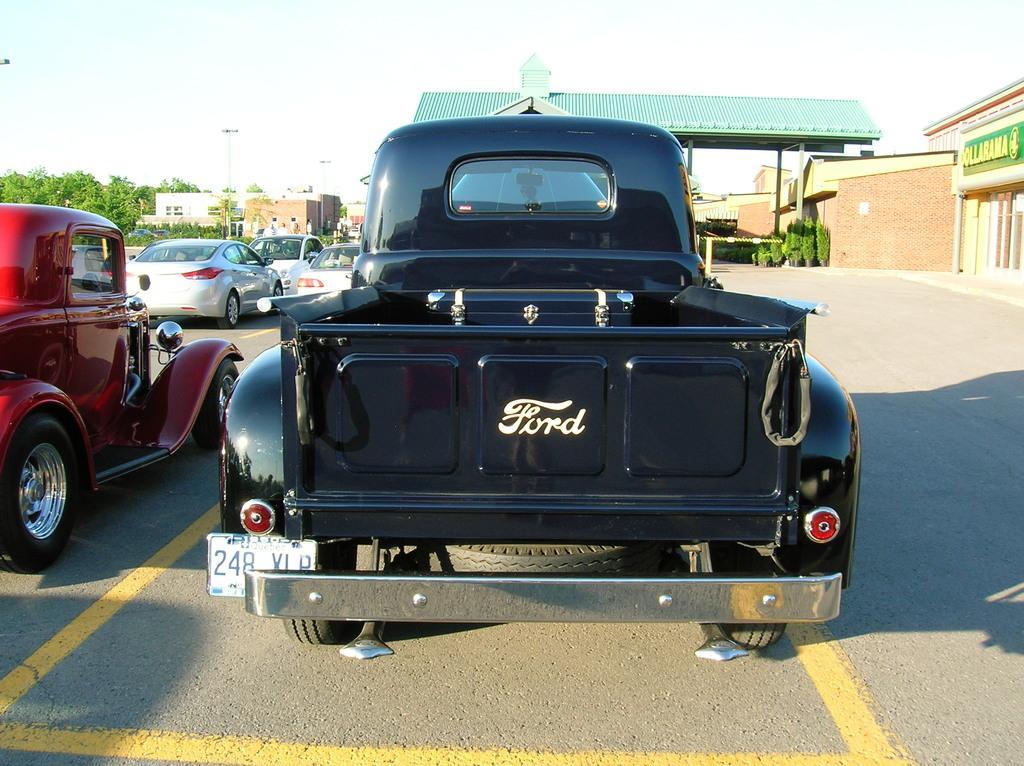How would you summarize this image in a sentence or two? In this image, there are a few vehicles, houses, poles, trees, plants. We can see the ground and the shed. We can see the sky and some text on the right. 